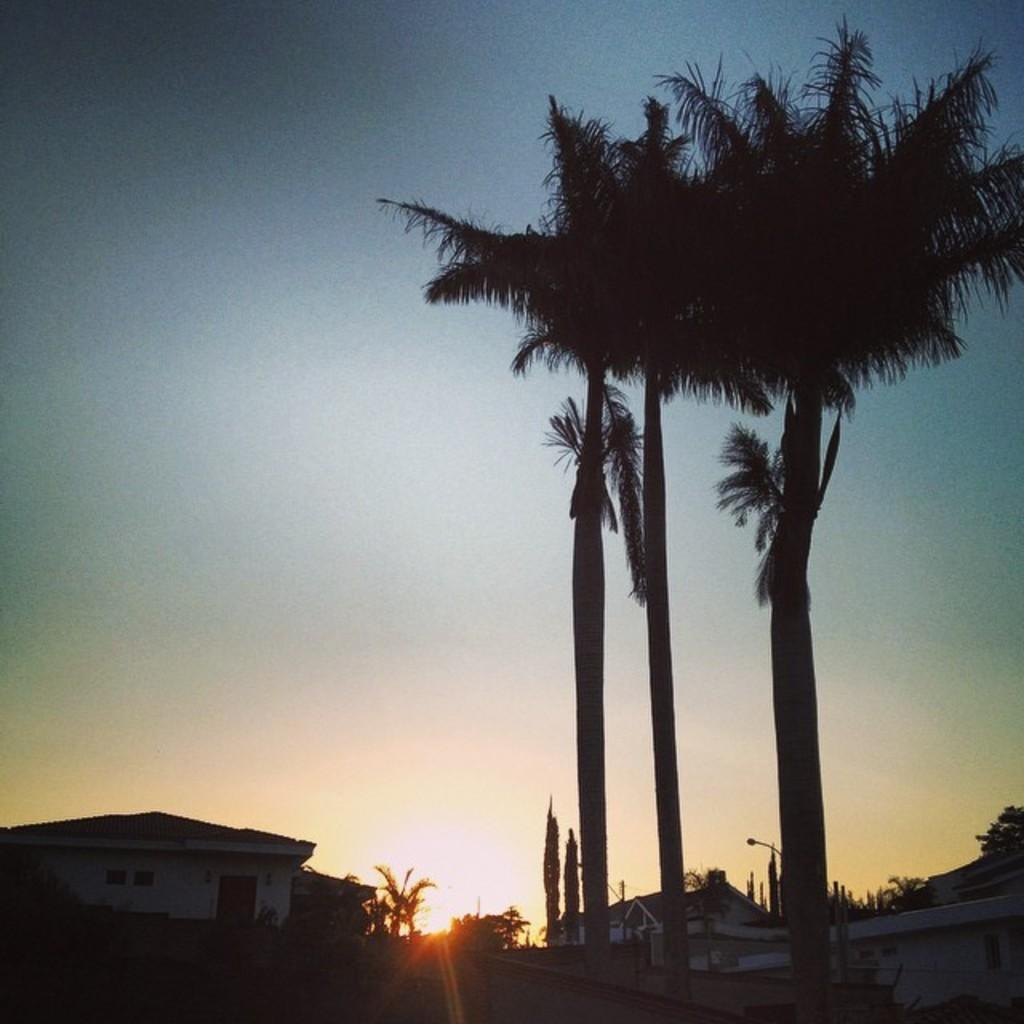What type of natural elements can be seen in the image? There are trees in the image. What type of man-made structures are visible in the image? There are houses in the image. What type of lighting is present in the image? A street light is present in the image. What else can be seen in the image besides trees, houses, and the street light? There are other objects in the image. What is visible in the background of the image? The sky is visible in the background of the image. Can the sun be seen in the sky? Yes, the sun is observable in the sky. How many chairs are visible in the image? There are no chairs present in the image. What type of building is shown in the image? There is no building shown in the image; only houses and trees are present. 